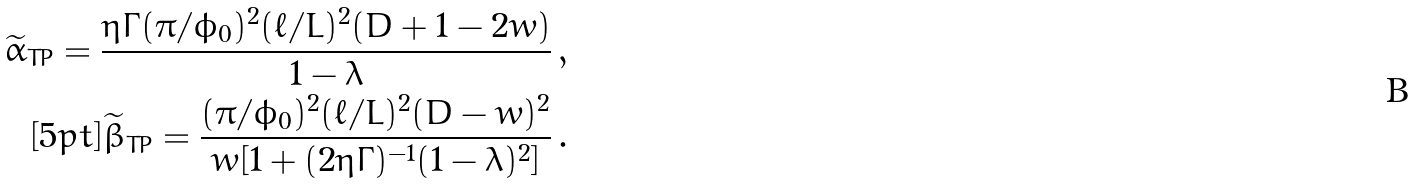<formula> <loc_0><loc_0><loc_500><loc_500>\widetilde { \alpha } _ { T P } = \frac { \eta \Gamma ( \pi / \phi _ { 0 } ) ^ { 2 } ( \ell / L ) ^ { 2 } ( D + 1 - 2 w ) } { 1 - \lambda } \, , \\ [ 5 p t ] \widetilde { \beta } _ { T P } = \frac { ( \pi / \phi _ { 0 } ) ^ { 2 } ( \ell / L ) ^ { 2 } ( D - w ) ^ { 2 } } { w [ 1 + ( 2 \eta \Gamma ) ^ { - 1 } ( 1 - \lambda ) ^ { 2 } ] } \, .</formula> 